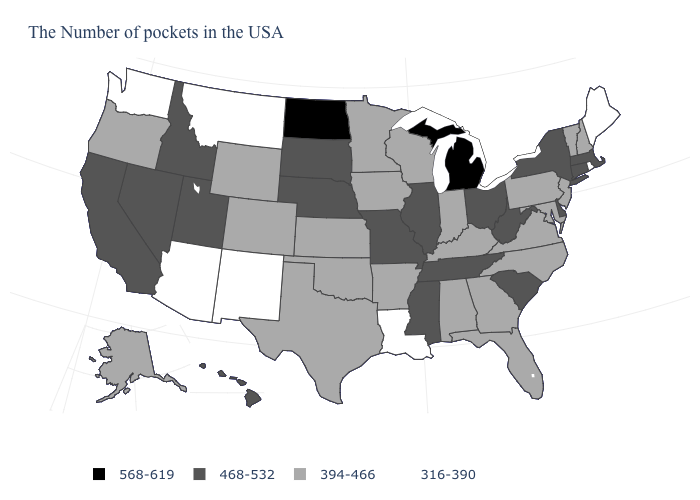What is the value of Maryland?
Short answer required. 394-466. What is the value of Virginia?
Answer briefly. 394-466. Name the states that have a value in the range 316-390?
Quick response, please. Maine, Rhode Island, Louisiana, New Mexico, Montana, Arizona, Washington. Does North Carolina have a higher value than Arkansas?
Quick response, please. No. What is the lowest value in the USA?
Answer briefly. 316-390. Which states have the highest value in the USA?
Give a very brief answer. Michigan, North Dakota. Does Michigan have the highest value in the USA?
Concise answer only. Yes. Does Nevada have the same value as Alaska?
Concise answer only. No. Name the states that have a value in the range 468-532?
Give a very brief answer. Massachusetts, Connecticut, New York, Delaware, South Carolina, West Virginia, Ohio, Tennessee, Illinois, Mississippi, Missouri, Nebraska, South Dakota, Utah, Idaho, Nevada, California, Hawaii. What is the value of Ohio?
Keep it brief. 468-532. Which states have the lowest value in the South?
Concise answer only. Louisiana. Among the states that border Oklahoma , which have the highest value?
Be succinct. Missouri. What is the lowest value in states that border Wyoming?
Concise answer only. 316-390. Name the states that have a value in the range 394-466?
Short answer required. New Hampshire, Vermont, New Jersey, Maryland, Pennsylvania, Virginia, North Carolina, Florida, Georgia, Kentucky, Indiana, Alabama, Wisconsin, Arkansas, Minnesota, Iowa, Kansas, Oklahoma, Texas, Wyoming, Colorado, Oregon, Alaska. What is the highest value in states that border New York?
Give a very brief answer. 468-532. 